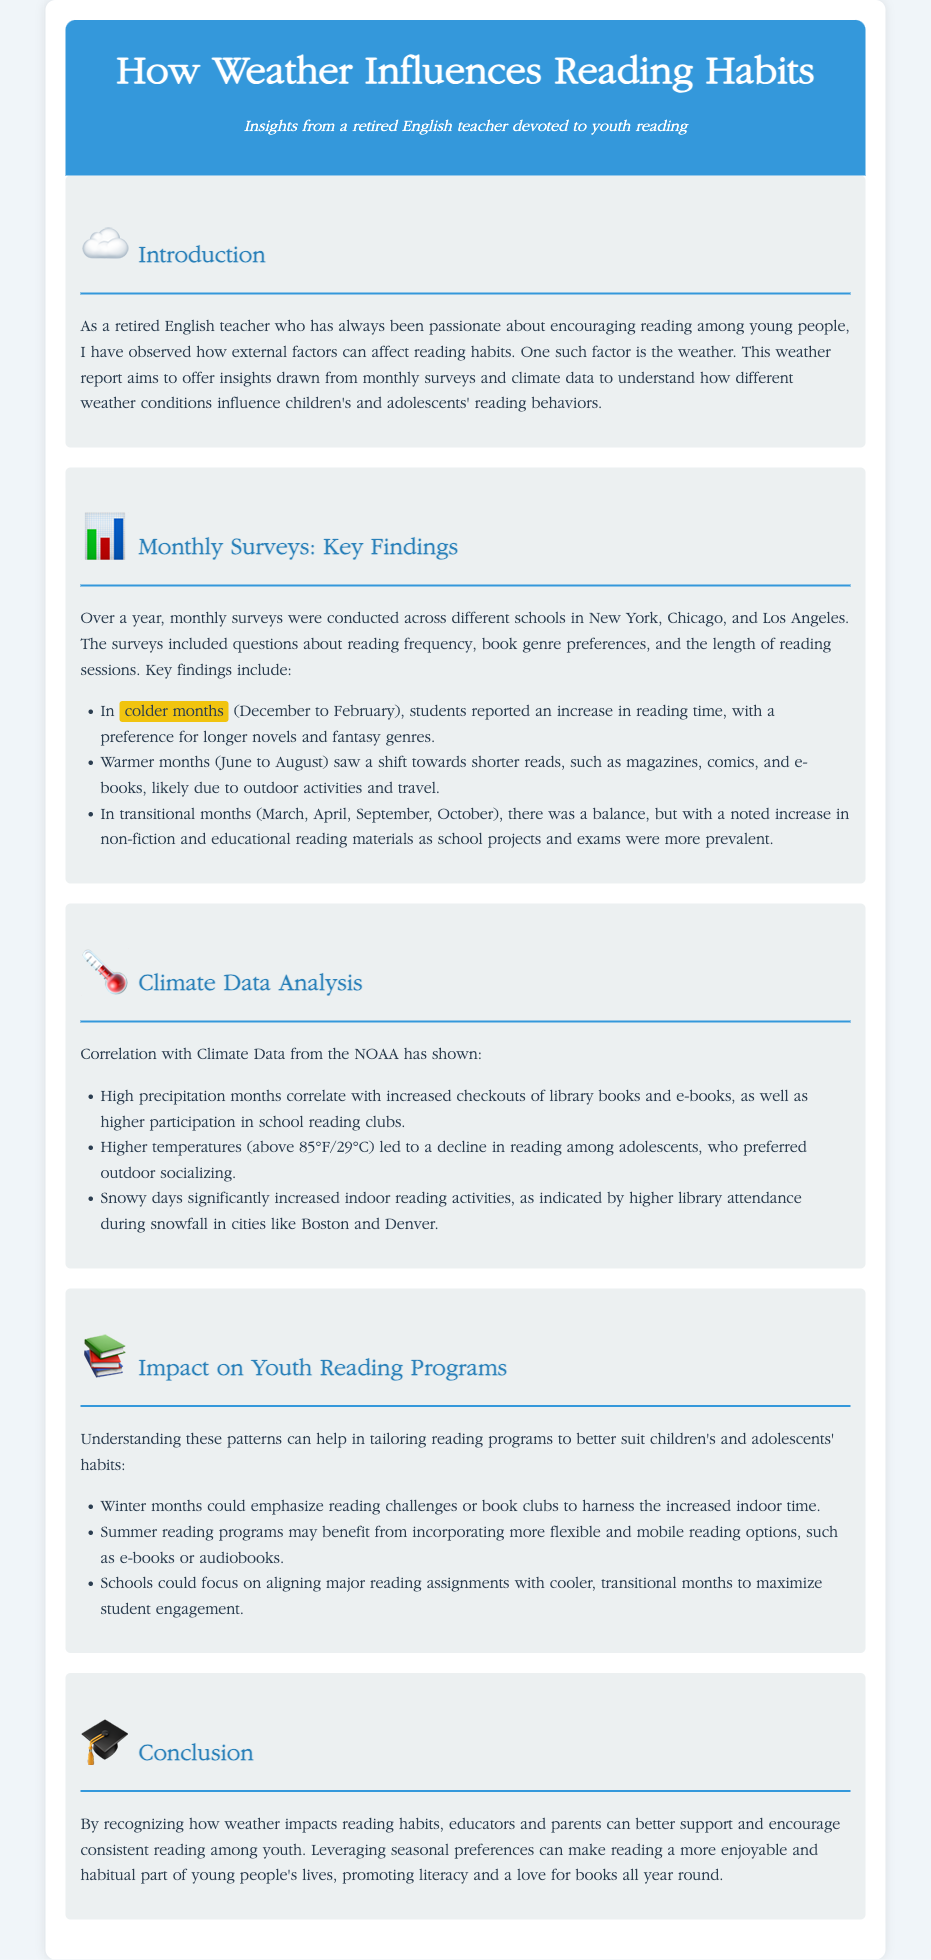What is the main purpose of the report? The main purpose is to understand how different weather conditions influence children's and adolescents' reading behaviors based on monthly surveys and climate data.
Answer: Understanding weather influence on reading In which months do students report increased reading time? Students reported increased reading time during colder months, specifically from December to February.
Answer: Colder months (December to February) What book genres are preferred in colder months? In colder months, students prefer longer novels and fantasy genres.
Answer: Longer novels and fantasy How do warmer months affect reading preferences? Warmer months lead to a shift towards shorter reads like magazines, comics, and e-books.
Answer: Shorter reads What happens during high precipitation months? High precipitation months correlate with increased checkouts of library books and e-books and higher participation in school reading clubs.
Answer: Increased checkouts and participation What impact do snowy days have on reading activities? Snowy days significantly increase indoor reading activities, resulting in higher library attendance during snowfall.
Answer: Higher library attendance What type of reading programs could be beneficial in winter? Winter months could emphasize reading challenges or book clubs to harness the increased indoor time.
Answer: Reading challenges or book clubs What does higher temperature (above 85°F) lead to? Higher temperatures lead to a decline in reading among adolescents, who prefer outdoor socializing.
Answer: Decline in reading How can understanding weather patterns help educators? Understanding these patterns can help tailor reading programs to better suit children's and adolescents' habits.
Answer: Tailor reading programs 